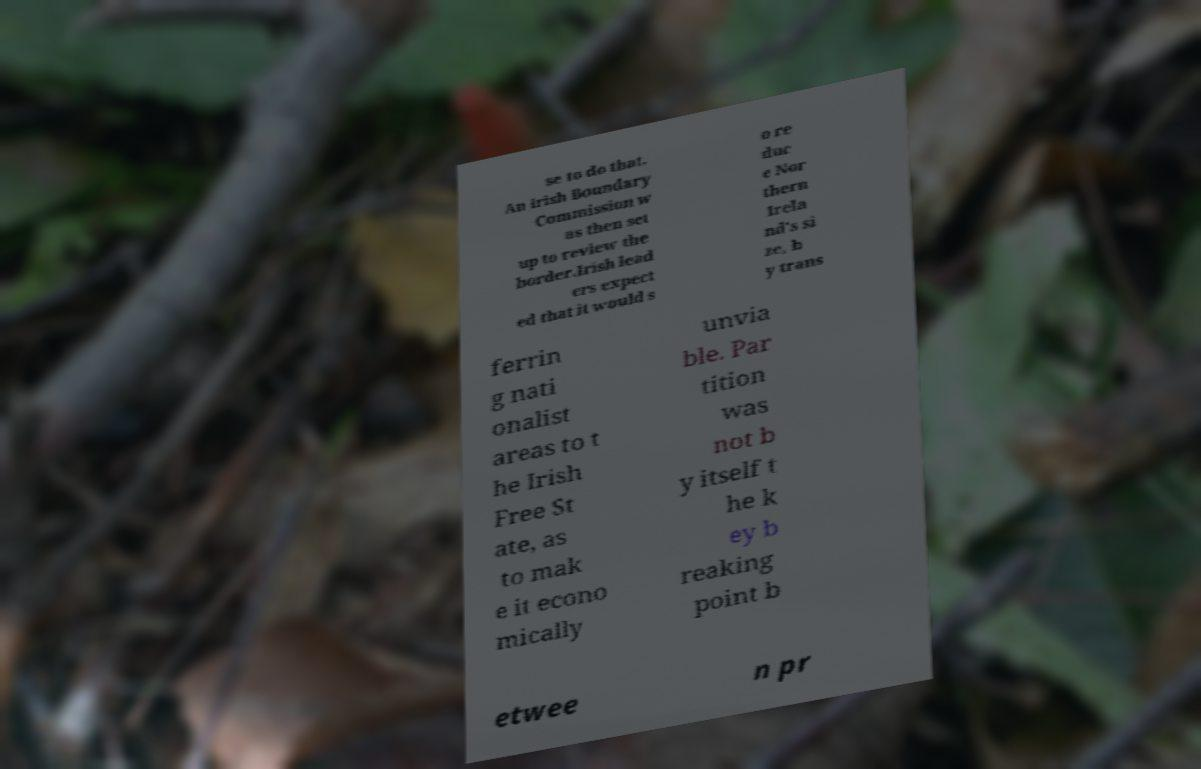Could you assist in decoding the text presented in this image and type it out clearly? se to do that. An Irish Boundary Commission w as then set up to review the border.Irish lead ers expect ed that it would s o re duc e Nor thern Irela nd's si ze, b y trans ferrin g nati onalist areas to t he Irish Free St ate, as to mak e it econo mically unvia ble. Par tition was not b y itself t he k ey b reaking point b etwee n pr 